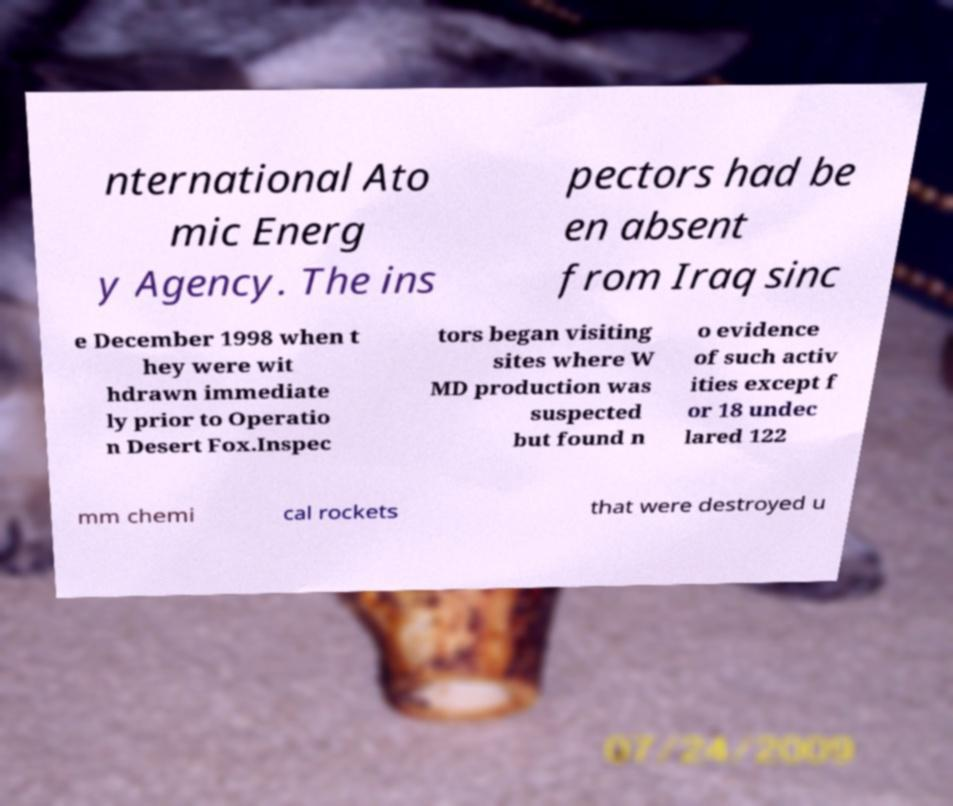Could you extract and type out the text from this image? nternational Ato mic Energ y Agency. The ins pectors had be en absent from Iraq sinc e December 1998 when t hey were wit hdrawn immediate ly prior to Operatio n Desert Fox.Inspec tors began visiting sites where W MD production was suspected but found n o evidence of such activ ities except f or 18 undec lared 122 mm chemi cal rockets that were destroyed u 